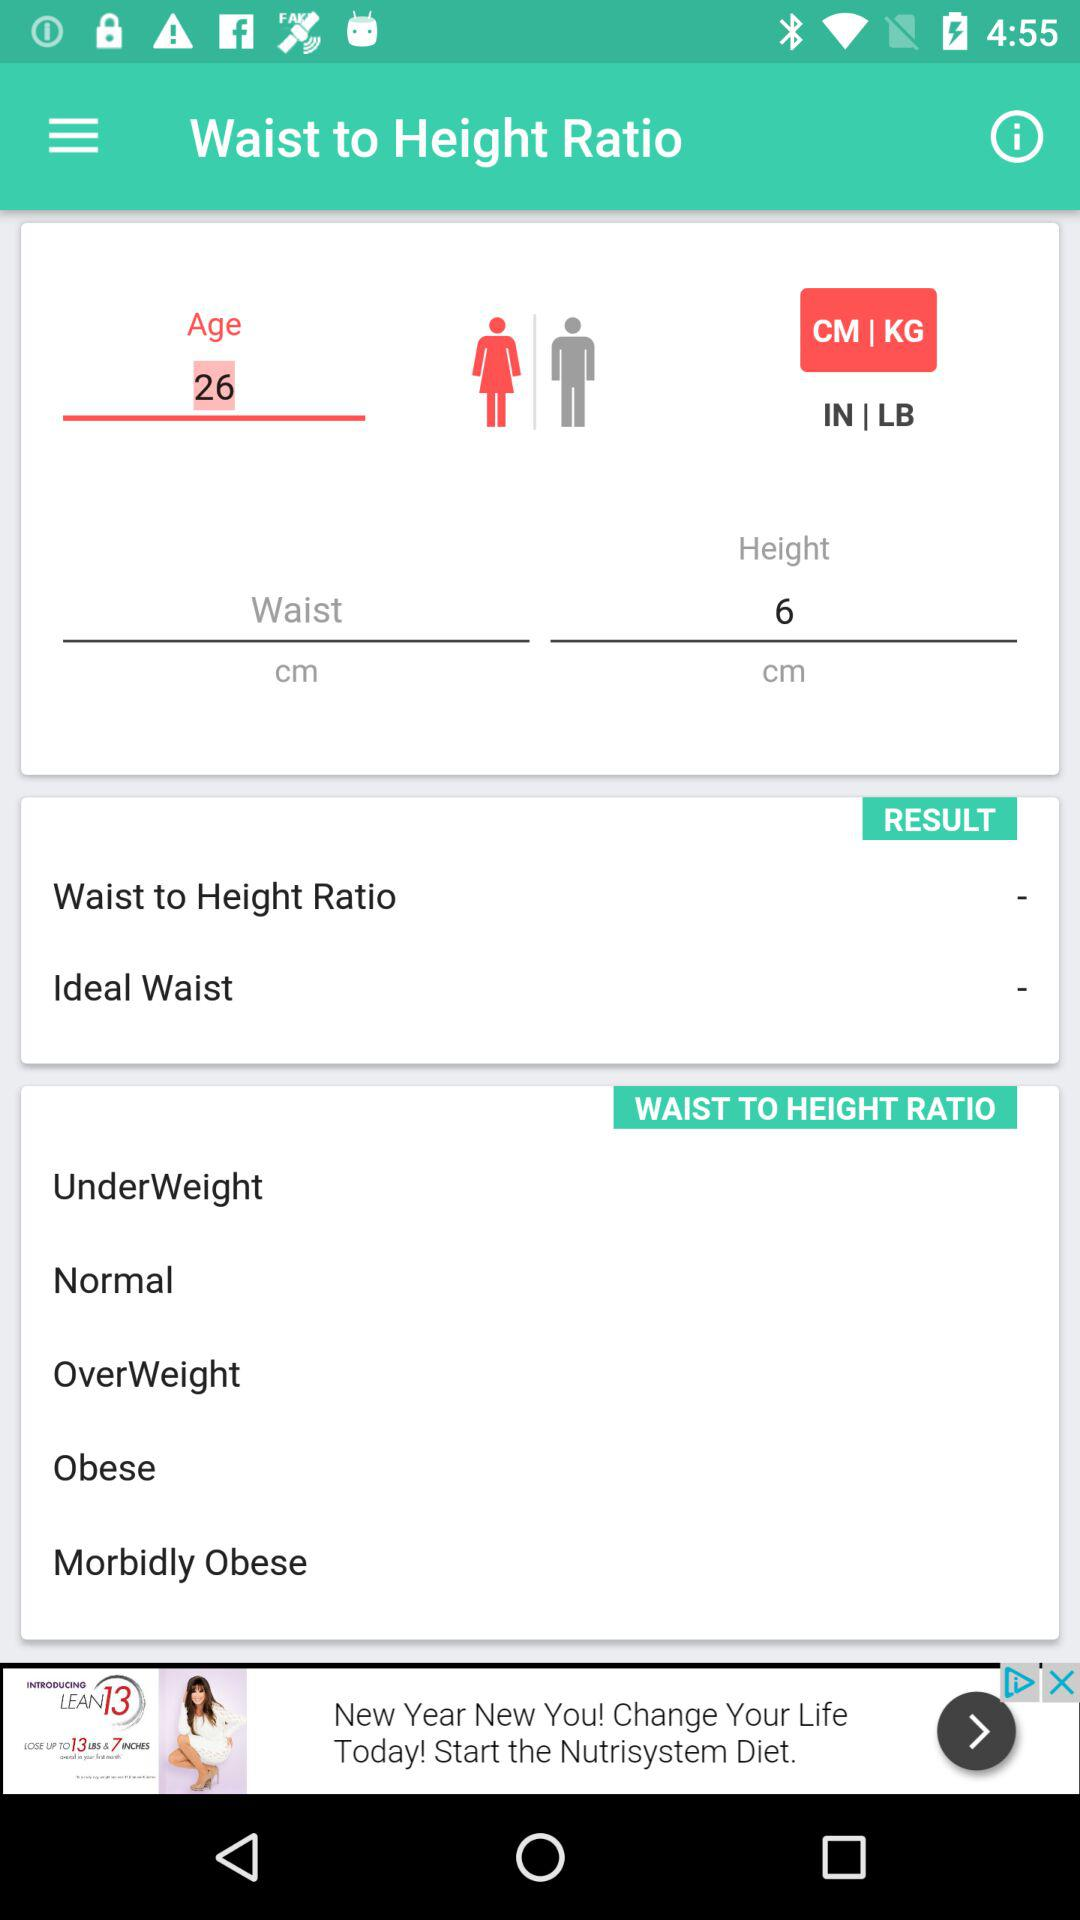What is the height? The height is 6 cm. 